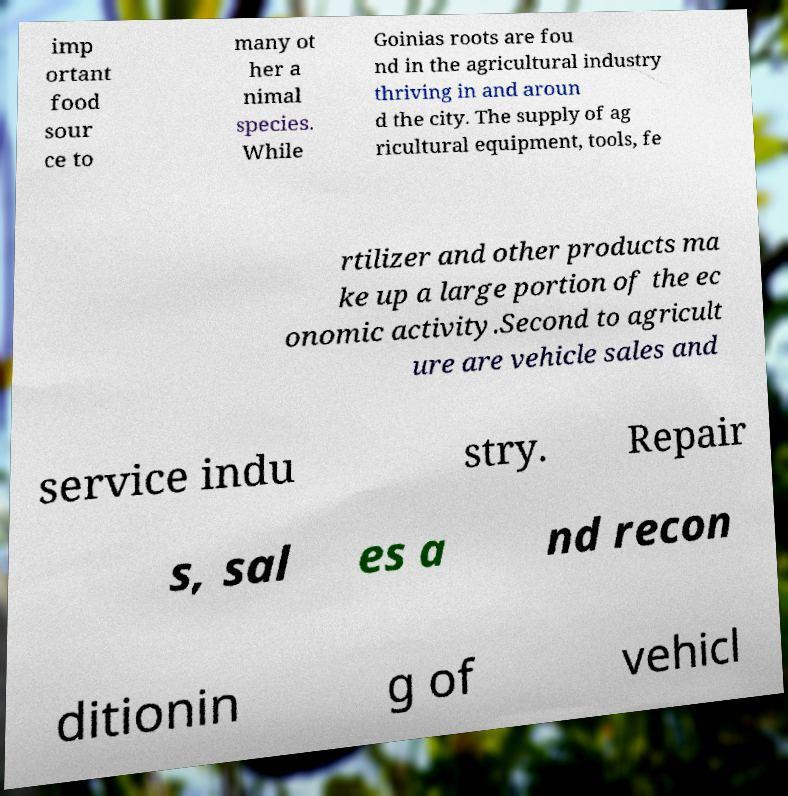Could you assist in decoding the text presented in this image and type it out clearly? imp ortant food sour ce to many ot her a nimal species. While Goinias roots are fou nd in the agricultural industry thriving in and aroun d the city. The supply of ag ricultural equipment, tools, fe rtilizer and other products ma ke up a large portion of the ec onomic activity.Second to agricult ure are vehicle sales and service indu stry. Repair s, sal es a nd recon ditionin g of vehicl 